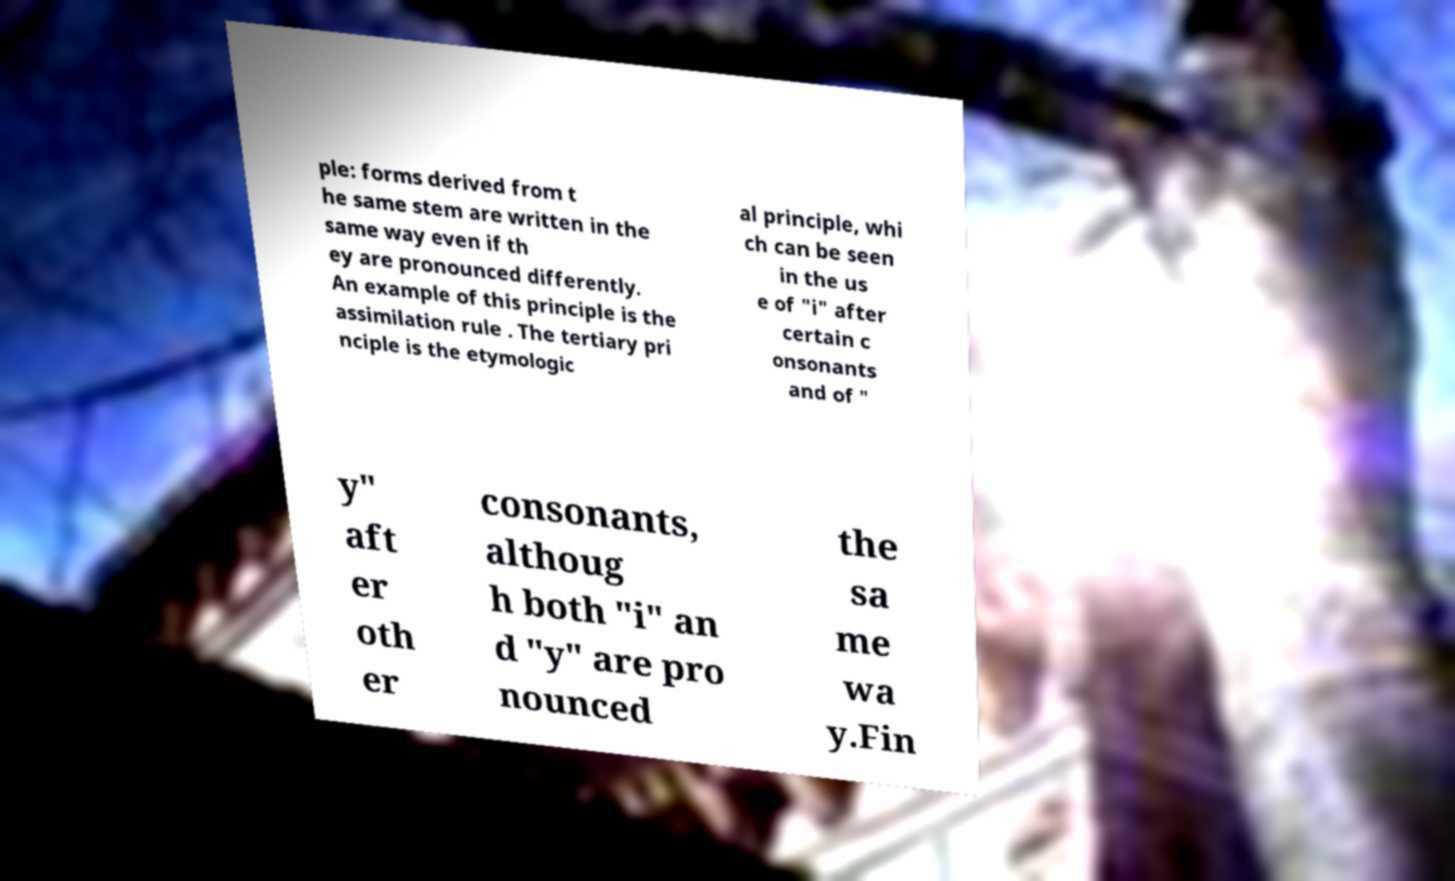Could you extract and type out the text from this image? ple: forms derived from t he same stem are written in the same way even if th ey are pronounced differently. An example of this principle is the assimilation rule . The tertiary pri nciple is the etymologic al principle, whi ch can be seen in the us e of "i" after certain c onsonants and of " y" aft er oth er consonants, althoug h both "i" an d "y" are pro nounced the sa me wa y.Fin 